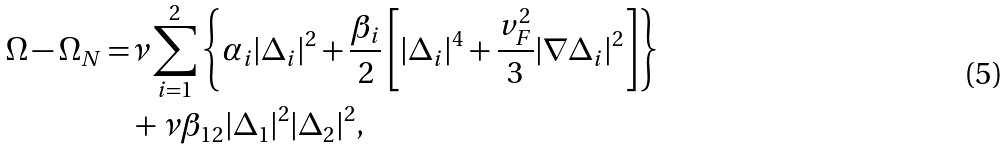Convert formula to latex. <formula><loc_0><loc_0><loc_500><loc_500>\Omega - \Omega _ { N } = & \nu \sum _ { i = 1 } ^ { 2 } \left \{ \alpha _ { i } | \Delta _ { i } | ^ { 2 } + \frac { \beta _ { i } } { 2 } \left [ | \Delta _ { i } | ^ { 4 } + \frac { v _ { F } ^ { 2 } } { 3 } | \nabla \Delta _ { i } | ^ { 2 } \right ] \right \} \\ & + \nu \beta _ { 1 2 } | \Delta _ { 1 } | ^ { 2 } | \Delta _ { 2 } | ^ { 2 } ,</formula> 